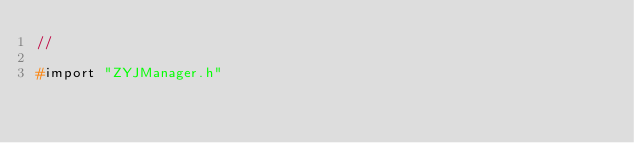<code> <loc_0><loc_0><loc_500><loc_500><_C_>//

#import "ZYJManager.h"
</code> 